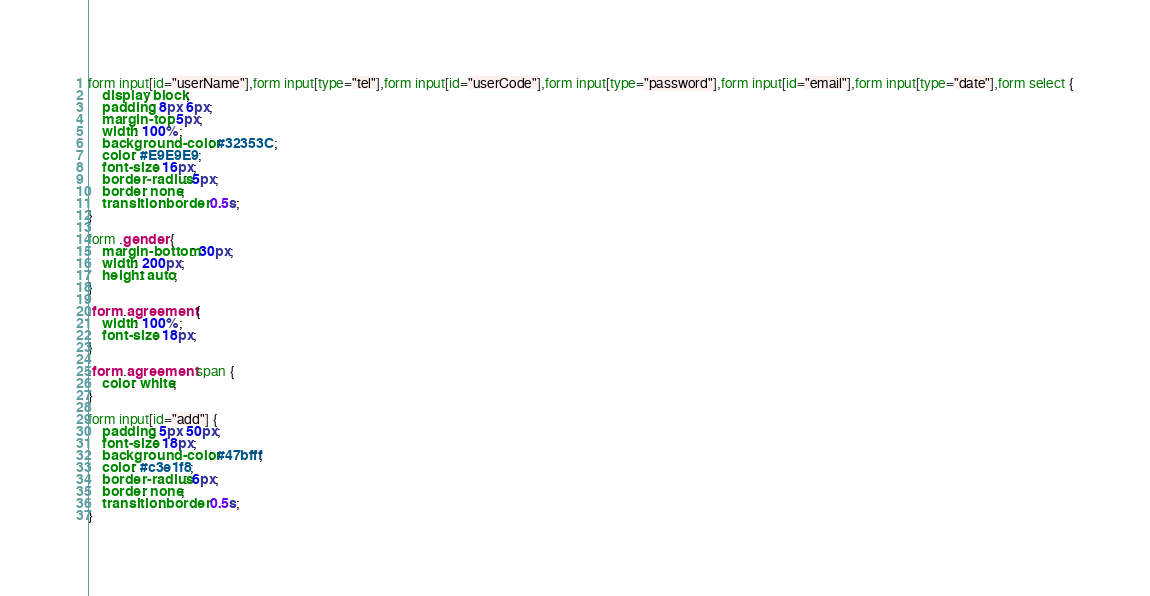<code> <loc_0><loc_0><loc_500><loc_500><_CSS_>
form input[id="userName"],form input[type="tel"],form input[id="userCode"],form input[type="password"],form input[id="email"],form input[type="date"],form select {
    display: block;
    padding: 8px 6px;
    margin-top: 5px;
    width: 100%;
    background-color: #32353C;
    color: #E9E9E9;
    font-size: 16px;
    border-radius: 5px;
    border: none;
    transition: border 0.5s;
}

form .gender {
    margin-bottom: 30px;
    width: 200px;
    height: auto;
}

.form .agreement {
    width: 100%;
    font-size: 18px;
}

.form .agreement span {
    color: white;
}

form input[id="add"] {
    padding: 5px 50px;
    font-size: 18px;
    background-color: #47bfff;
    color: #c3e1f8;
    border-radius: 6px;
    border: none;
    transition: border 0.5s;
}</code> 